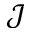<formula> <loc_0><loc_0><loc_500><loc_500>\mathcal { J }</formula> 